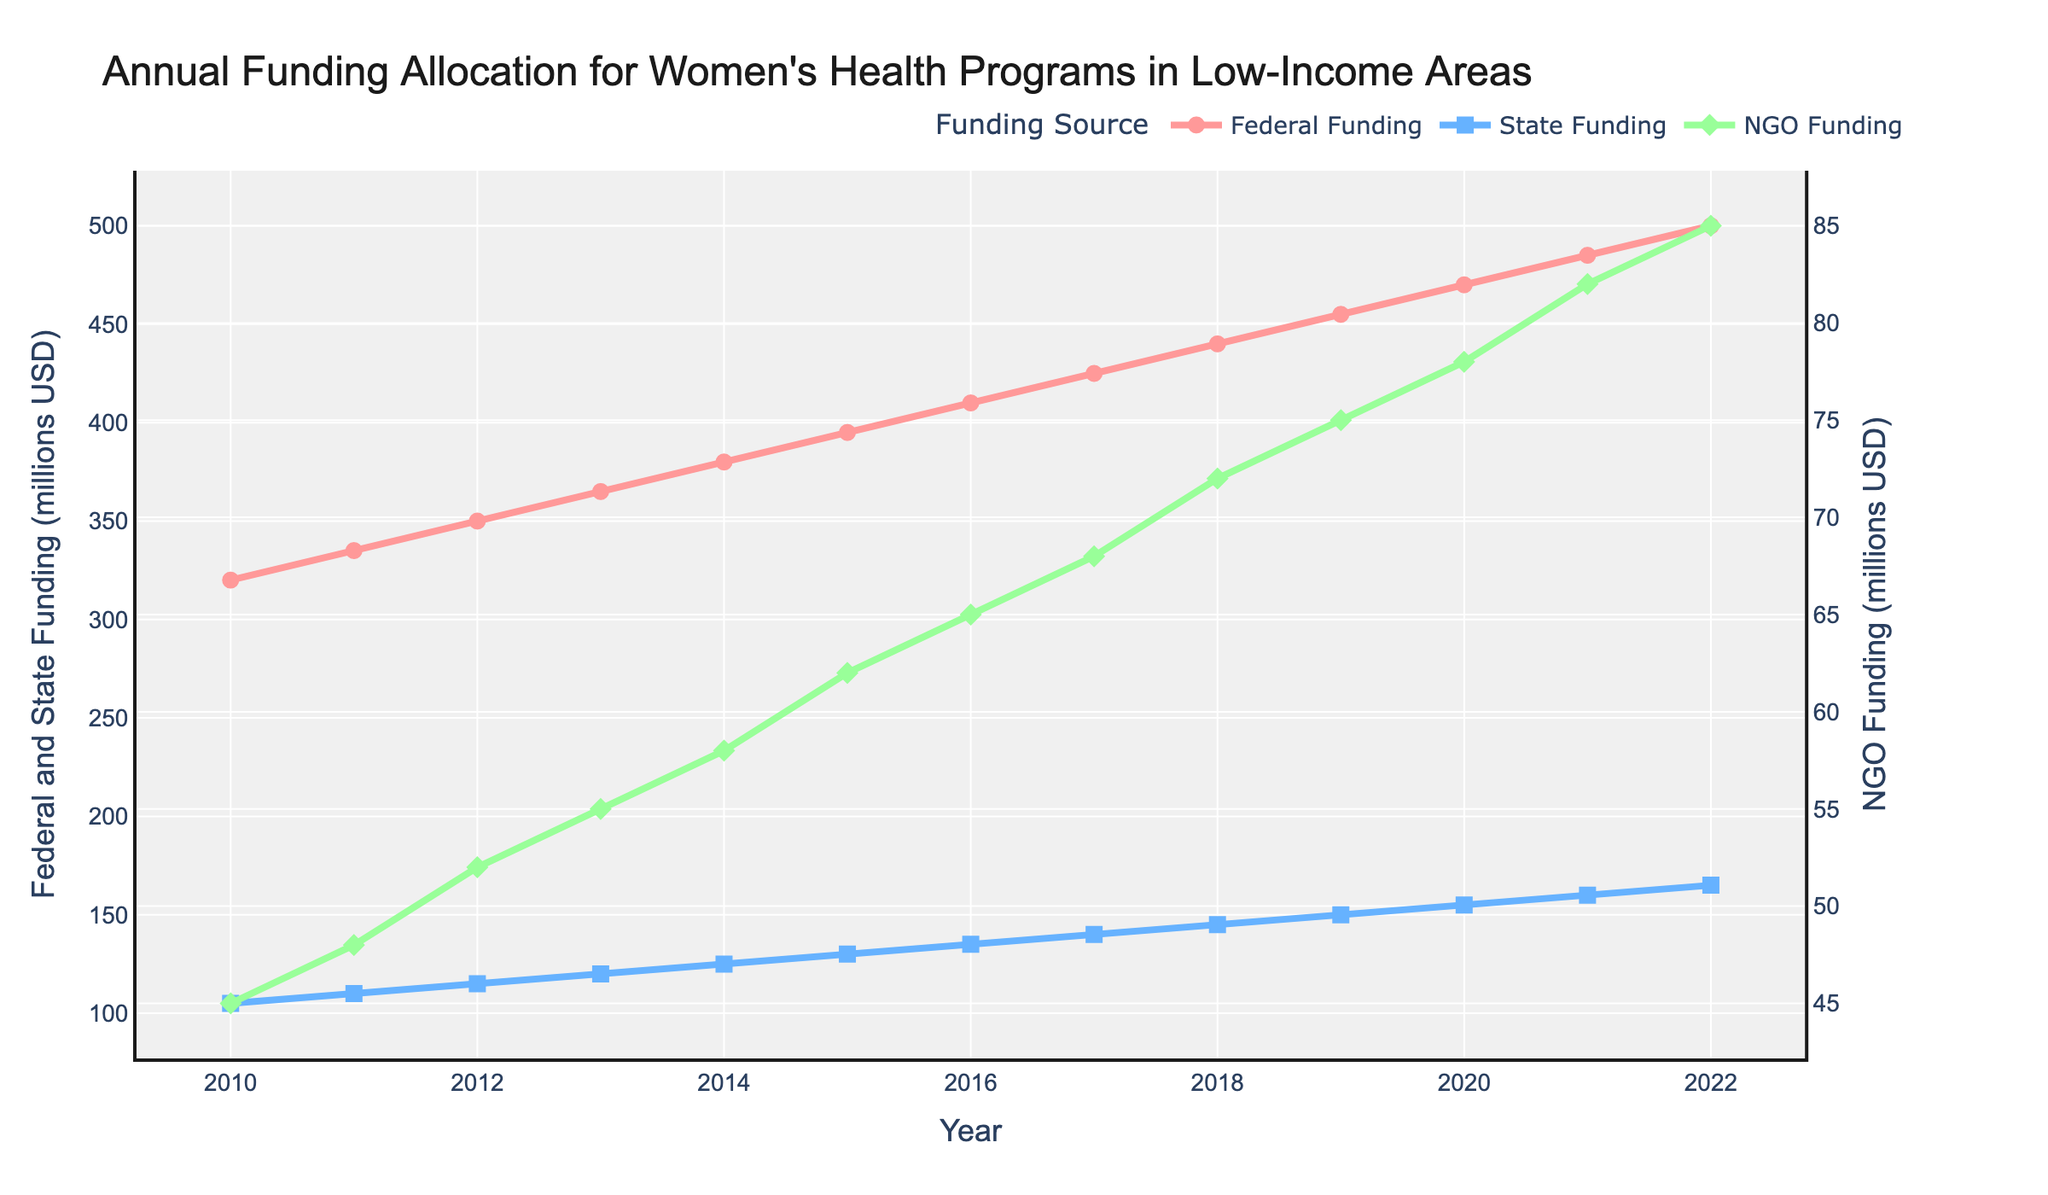What is the total funding (Federal, State, and NGO) for 2022? Add the values of Federal, State, and NGO funding for 2022. Federal: 500 million, State: 165 million, NGO: 85 million. Total = 500 + 165 + 85 = 750 million USD
Answer: 750 million USD In what year did the State Funding first reach 150 million USD? Identify the year where State Funding becomes 150 million USD for the first time. This occurred in 2019.
Answer: 2019 How much did Federal Funding increase from 2010 to 2022? Subtract the Federal Funding value in 2010 from that in 2022. 2022: 500 million, 2010: 320 million. Increase = 500 - 320 = 180 million USD
Answer: 180 million USD Which funding source showed the highest annual increase between 2011 and 2012? Calculate the increase for each funding source between 2011 and 2012. Federal: 350 - 335 = 15 million, State: 115 - 110 = 5 million, NGO: 52 - 48 = 4 million. Federal Funding had the highest increase.
Answer: Federal Funding Compare the Federal and NGO Funding in 2020. How many times higher is Federal Funding compared to NGO Funding in that year? Calculate the ratio of Federal Funding to NGO Funding in 2020. Federal: 470 million, NGO: 78 million. Ratio = 470 / 78 ≈ 6.03
Answer: About 6 times What is the average State Funding from 2010 to 2022? Add all State Funding values from 2010 to 2022 and divide by the number of years. Sum = 105 + 110 + 115 + 120 + 125 + 130 + 135 + 140 + 145 + 150 + 155 + 160 + 165 = 1765. Average = 1765 / 13 ≈ 135.77 million USD
Answer: About 135.77 million USD Which funding source reached 100 million USD first and in what year? Identify the first occurrence where any funding source reaches 100 million USD. State Funding reached it in 2010, while others reached it later.
Answer: State Funding in 2010 How does the trend of NGO Funding compare to Federal Funding from 2010 to 2022? Federal Funding consistently increases at a constant rate, while NGO Funding also increases but at a slower rate and with smaller absolute values
Answer: NGO Funding increases slower than Federal Funding What was the increase in State Funding from 2014 to 2019? Subtract the State Funding value in 2014 from that in 2019. 2019: 150 million, 2014: 125 million. Increase = 150 - 125 = 25 million USD
Answer: 25 million USD Which funding source had the smallest total funding from 2010 to 2022? Sum the total funding for each source over the years and compare. Federal: 5075 million, State: 1765 million, NGO: 855 million. NGO Funding has the smallest total.
Answer: NGO Funding 